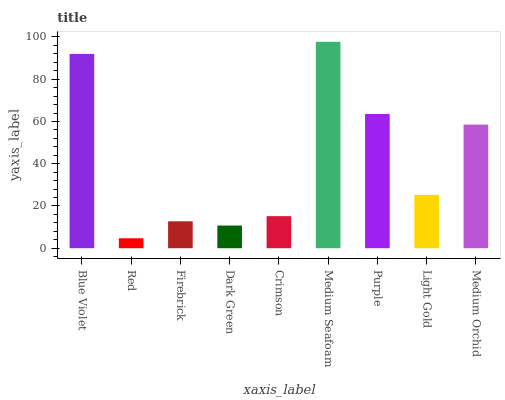Is Red the minimum?
Answer yes or no. Yes. Is Medium Seafoam the maximum?
Answer yes or no. Yes. Is Firebrick the minimum?
Answer yes or no. No. Is Firebrick the maximum?
Answer yes or no. No. Is Firebrick greater than Red?
Answer yes or no. Yes. Is Red less than Firebrick?
Answer yes or no. Yes. Is Red greater than Firebrick?
Answer yes or no. No. Is Firebrick less than Red?
Answer yes or no. No. Is Light Gold the high median?
Answer yes or no. Yes. Is Light Gold the low median?
Answer yes or no. Yes. Is Purple the high median?
Answer yes or no. No. Is Medium Seafoam the low median?
Answer yes or no. No. 